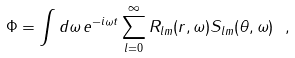Convert formula to latex. <formula><loc_0><loc_0><loc_500><loc_500>\Phi = \int d \omega \, e ^ { - i \omega t } \sum _ { l = 0 } ^ { \infty } R _ { l m } ( r , \omega ) S _ { l m } ( \theta , \omega ) \ ,</formula> 